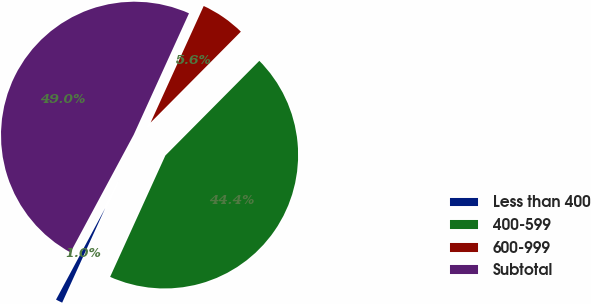Convert chart. <chart><loc_0><loc_0><loc_500><loc_500><pie_chart><fcel>Less than 400<fcel>400-599<fcel>600-999<fcel>Subtotal<nl><fcel>1.05%<fcel>44.36%<fcel>5.64%<fcel>48.95%<nl></chart> 